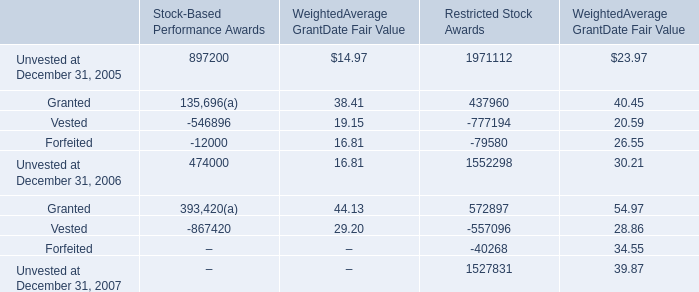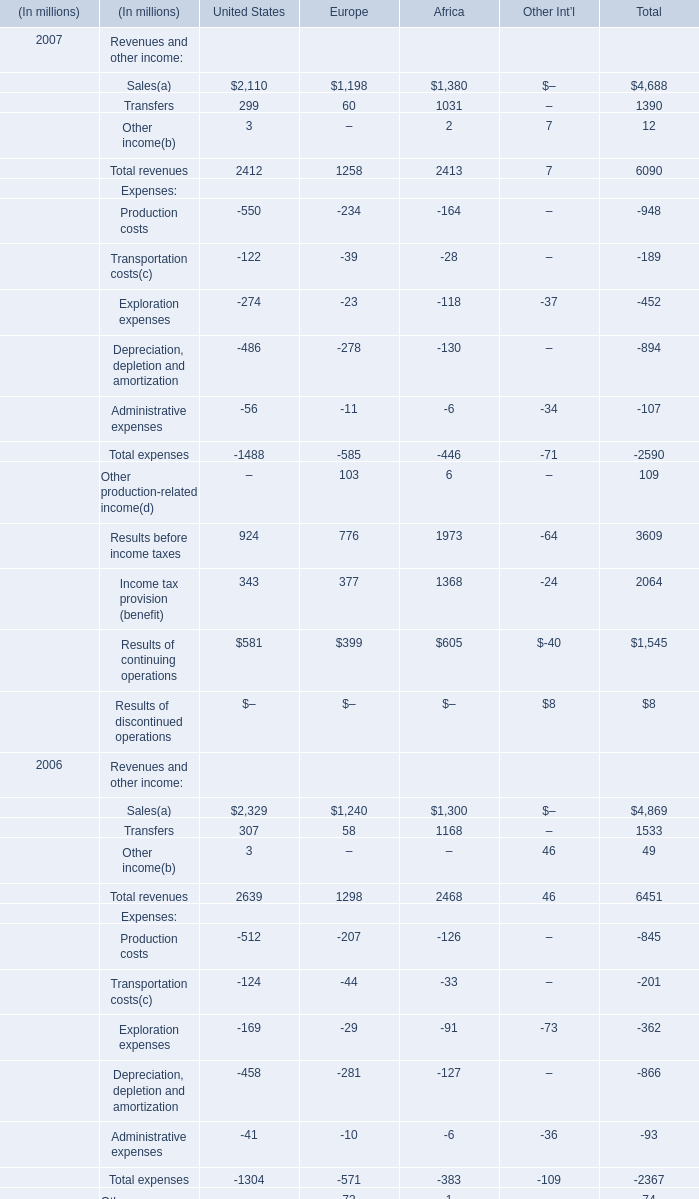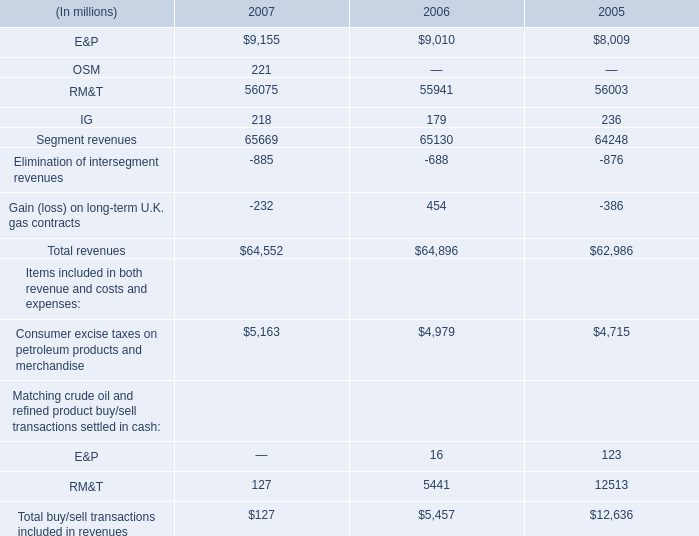What is the growing rate of Total revenues in the years for United States with the least Sales? 
Computations: ((2412 - 2639) / 2412)
Answer: -0.09411. What is the total amount of Stock-Based Performance Awards and Restricted Stock Awards for Unvested at December 31, 2006? 
Computations: (474000 + 1552298)
Answer: 2026298.0. 